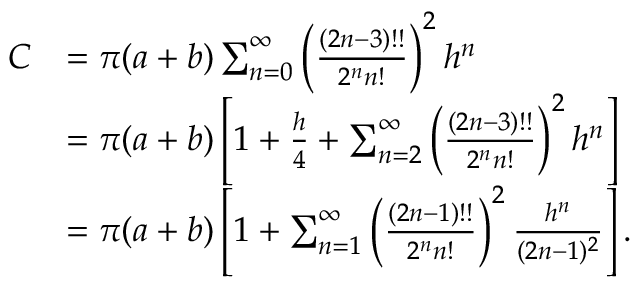Convert formula to latex. <formula><loc_0><loc_0><loc_500><loc_500>{ \begin{array} { r l } { C } & { = \pi ( a + b ) \sum _ { n = 0 } ^ { \infty } \left ( { \frac { ( 2 n - 3 ) ! ! } { 2 ^ { n } n ! } } \right ) ^ { 2 } h ^ { n } } \\ & { = \pi ( a + b ) \left [ 1 + { \frac { h } { 4 } } + \sum _ { n = 2 } ^ { \infty } \left ( { \frac { ( 2 n - 3 ) ! ! } { 2 ^ { n } n ! } } \right ) ^ { 2 } h ^ { n } \right ] } \\ & { = \pi ( a + b ) \left [ 1 + \sum _ { n = 1 } ^ { \infty } \left ( { \frac { ( 2 n - 1 ) ! ! } { 2 ^ { n } n ! } } \right ) ^ { 2 } { \frac { h ^ { n } } { ( 2 n - 1 ) ^ { 2 } } } \right ] . } \end{array} }</formula> 